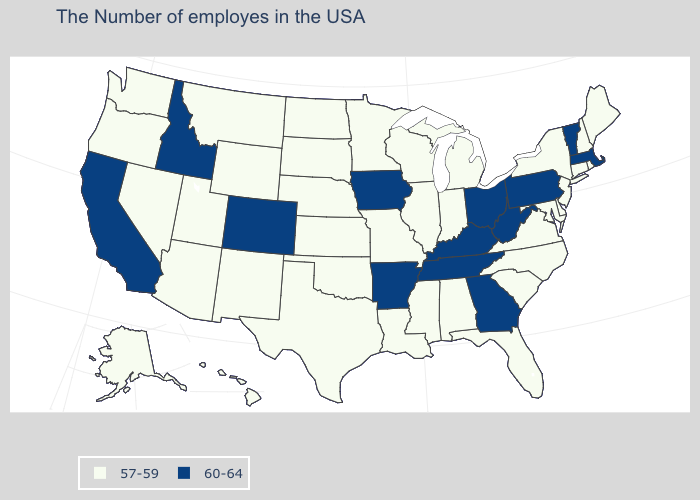Name the states that have a value in the range 60-64?
Keep it brief. Massachusetts, Vermont, Pennsylvania, West Virginia, Ohio, Georgia, Kentucky, Tennessee, Arkansas, Iowa, Colorado, Idaho, California. Among the states that border Florida , which have the highest value?
Write a very short answer. Georgia. Does the map have missing data?
Answer briefly. No. Among the states that border Rhode Island , which have the lowest value?
Quick response, please. Connecticut. What is the lowest value in the USA?
Give a very brief answer. 57-59. Among the states that border California , which have the lowest value?
Be succinct. Arizona, Nevada, Oregon. What is the value of Nevada?
Quick response, please. 57-59. What is the value of Vermont?
Quick response, please. 60-64. Name the states that have a value in the range 60-64?
Short answer required. Massachusetts, Vermont, Pennsylvania, West Virginia, Ohio, Georgia, Kentucky, Tennessee, Arkansas, Iowa, Colorado, Idaho, California. What is the lowest value in the USA?
Be succinct. 57-59. Name the states that have a value in the range 57-59?
Short answer required. Maine, Rhode Island, New Hampshire, Connecticut, New York, New Jersey, Delaware, Maryland, Virginia, North Carolina, South Carolina, Florida, Michigan, Indiana, Alabama, Wisconsin, Illinois, Mississippi, Louisiana, Missouri, Minnesota, Kansas, Nebraska, Oklahoma, Texas, South Dakota, North Dakota, Wyoming, New Mexico, Utah, Montana, Arizona, Nevada, Washington, Oregon, Alaska, Hawaii. What is the value of Nevada?
Give a very brief answer. 57-59. Which states hav the highest value in the Northeast?
Quick response, please. Massachusetts, Vermont, Pennsylvania. What is the value of Hawaii?
Short answer required. 57-59. Which states have the lowest value in the USA?
Quick response, please. Maine, Rhode Island, New Hampshire, Connecticut, New York, New Jersey, Delaware, Maryland, Virginia, North Carolina, South Carolina, Florida, Michigan, Indiana, Alabama, Wisconsin, Illinois, Mississippi, Louisiana, Missouri, Minnesota, Kansas, Nebraska, Oklahoma, Texas, South Dakota, North Dakota, Wyoming, New Mexico, Utah, Montana, Arizona, Nevada, Washington, Oregon, Alaska, Hawaii. 